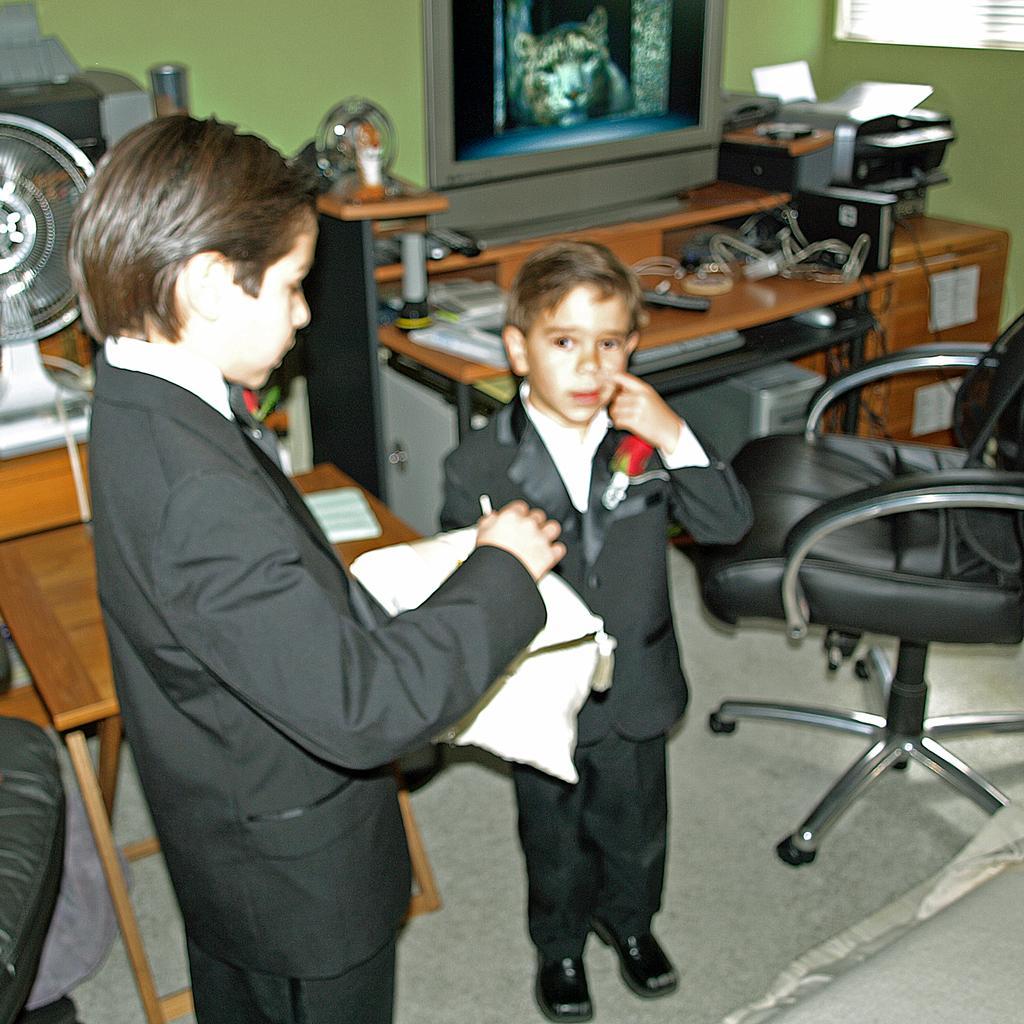Can you describe this image briefly? In this image, In the right side there is a chair which is in black color, on that table there are some objects kept, There is a television which is in ash color kept on the table, In the left side there are boy standing in the background there are some yellow color table there is a fan on the table, There is a green color wall. 